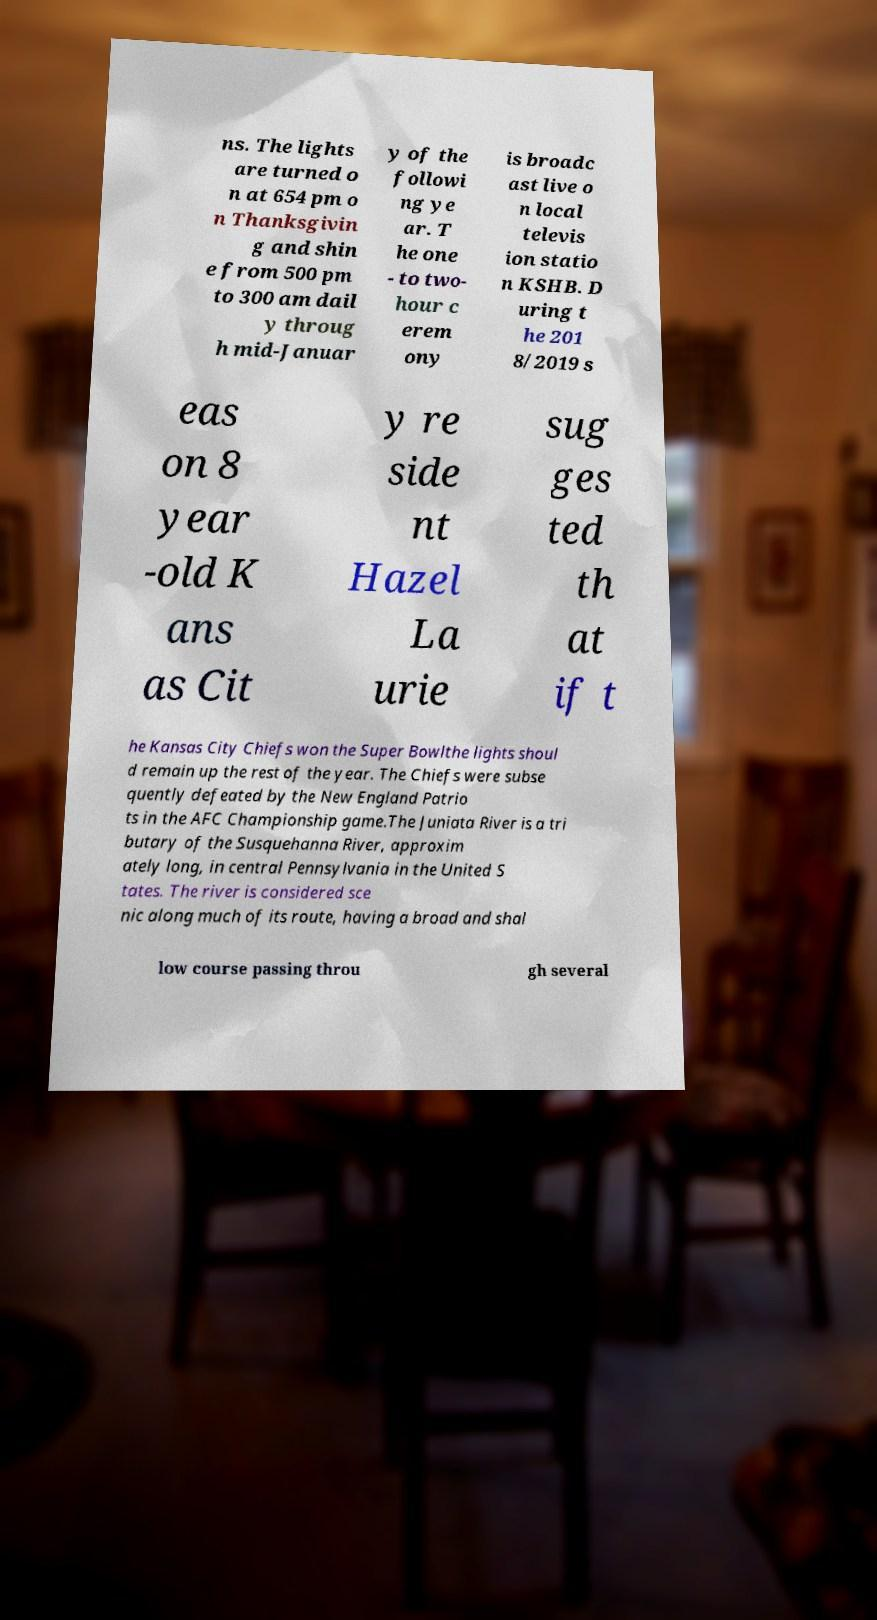Can you accurately transcribe the text from the provided image for me? ns. The lights are turned o n at 654 pm o n Thanksgivin g and shin e from 500 pm to 300 am dail y throug h mid-Januar y of the followi ng ye ar. T he one - to two- hour c erem ony is broadc ast live o n local televis ion statio n KSHB. D uring t he 201 8/2019 s eas on 8 year -old K ans as Cit y re side nt Hazel La urie sug ges ted th at if t he Kansas City Chiefs won the Super Bowlthe lights shoul d remain up the rest of the year. The Chiefs were subse quently defeated by the New England Patrio ts in the AFC Championship game.The Juniata River is a tri butary of the Susquehanna River, approxim ately long, in central Pennsylvania in the United S tates. The river is considered sce nic along much of its route, having a broad and shal low course passing throu gh several 